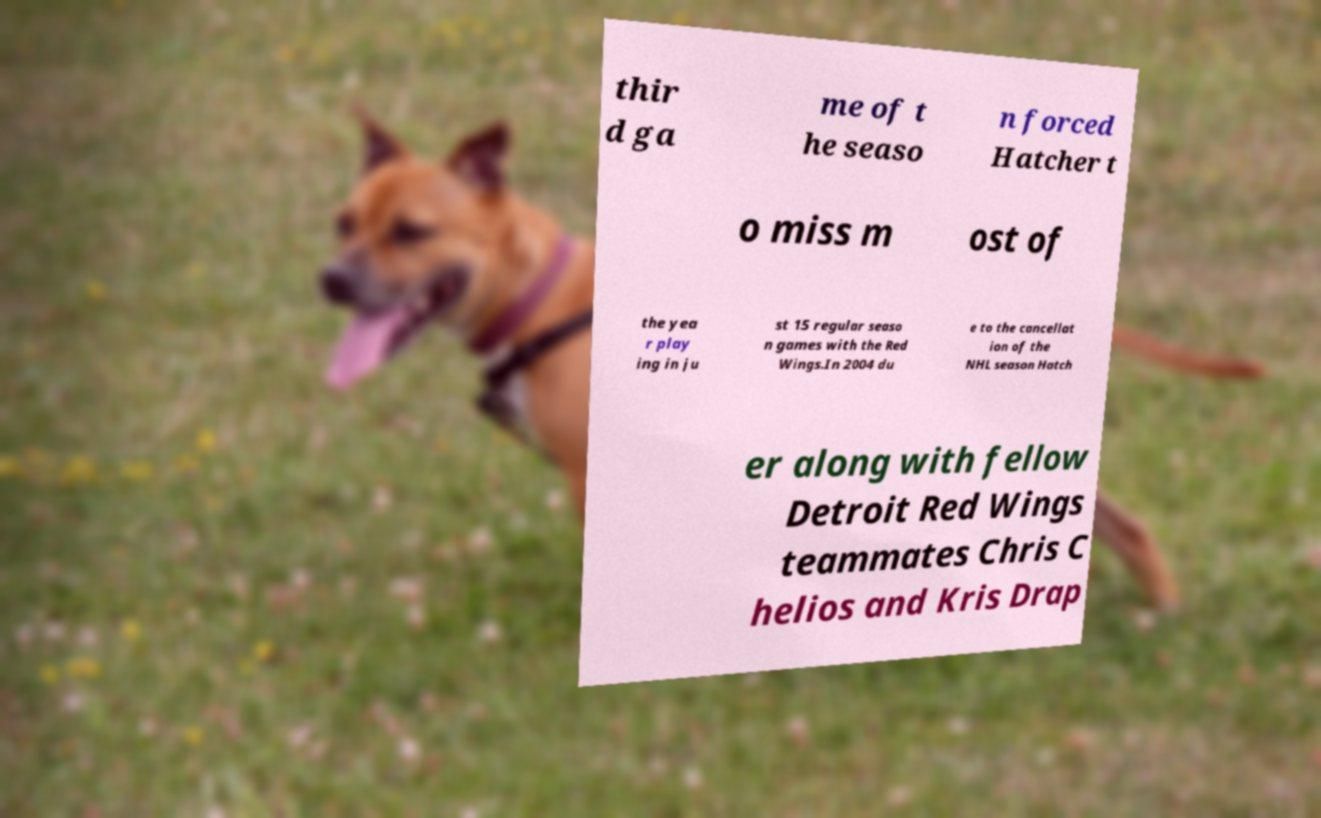Please identify and transcribe the text found in this image. thir d ga me of t he seaso n forced Hatcher t o miss m ost of the yea r play ing in ju st 15 regular seaso n games with the Red Wings.In 2004 du e to the cancellat ion of the NHL season Hatch er along with fellow Detroit Red Wings teammates Chris C helios and Kris Drap 